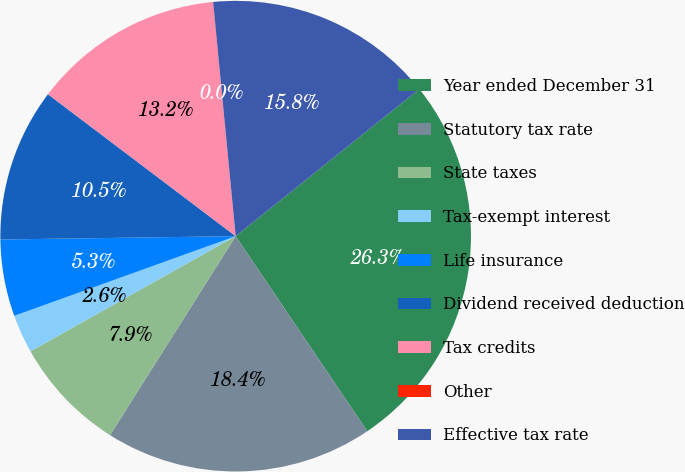<chart> <loc_0><loc_0><loc_500><loc_500><pie_chart><fcel>Year ended December 31<fcel>Statutory tax rate<fcel>State taxes<fcel>Tax-exempt interest<fcel>Life insurance<fcel>Dividend received deduction<fcel>Tax credits<fcel>Other<fcel>Effective tax rate<nl><fcel>26.3%<fcel>18.41%<fcel>7.9%<fcel>2.64%<fcel>5.27%<fcel>10.53%<fcel>13.16%<fcel>0.01%<fcel>15.78%<nl></chart> 